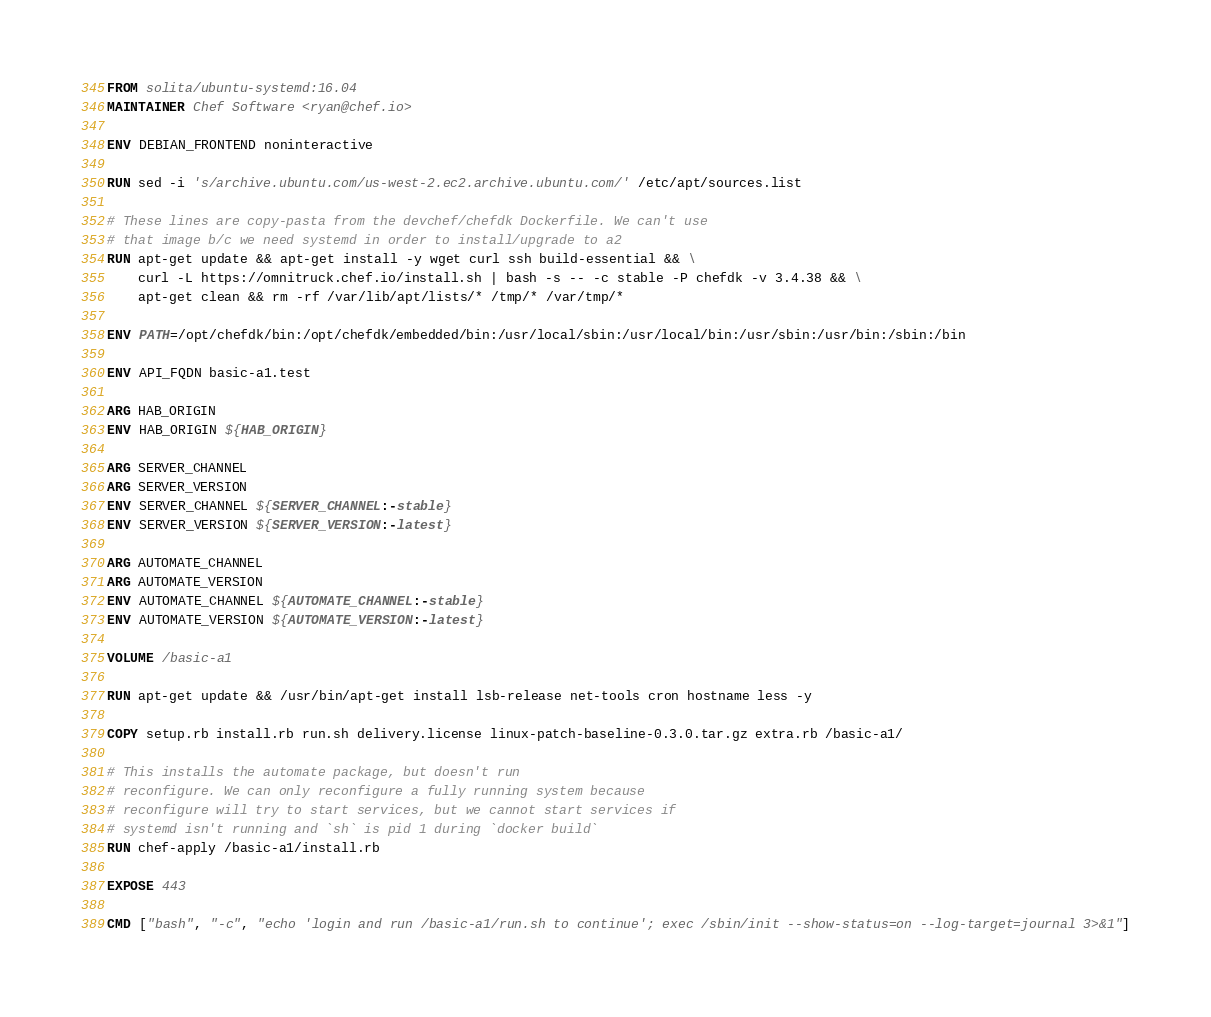Convert code to text. <code><loc_0><loc_0><loc_500><loc_500><_Dockerfile_>FROM solita/ubuntu-systemd:16.04
MAINTAINER Chef Software <ryan@chef.io>

ENV DEBIAN_FRONTEND noninteractive

RUN sed -i 's/archive.ubuntu.com/us-west-2.ec2.archive.ubuntu.com/' /etc/apt/sources.list

# These lines are copy-pasta from the devchef/chefdk Dockerfile. We can't use
# that image b/c we need systemd in order to install/upgrade to a2
RUN apt-get update && apt-get install -y wget curl ssh build-essential && \
    curl -L https://omnitruck.chef.io/install.sh | bash -s -- -c stable -P chefdk -v 3.4.38 && \
    apt-get clean && rm -rf /var/lib/apt/lists/* /tmp/* /var/tmp/*

ENV PATH=/opt/chefdk/bin:/opt/chefdk/embedded/bin:/usr/local/sbin:/usr/local/bin:/usr/sbin:/usr/bin:/sbin:/bin

ENV API_FQDN basic-a1.test

ARG HAB_ORIGIN
ENV HAB_ORIGIN ${HAB_ORIGIN}

ARG SERVER_CHANNEL
ARG SERVER_VERSION
ENV SERVER_CHANNEL ${SERVER_CHANNEL:-stable}
ENV SERVER_VERSION ${SERVER_VERSION:-latest}

ARG AUTOMATE_CHANNEL
ARG AUTOMATE_VERSION
ENV AUTOMATE_CHANNEL ${AUTOMATE_CHANNEL:-stable}
ENV AUTOMATE_VERSION ${AUTOMATE_VERSION:-latest}

VOLUME /basic-a1

RUN apt-get update && /usr/bin/apt-get install lsb-release net-tools cron hostname less -y

COPY setup.rb install.rb run.sh delivery.license linux-patch-baseline-0.3.0.tar.gz extra.rb /basic-a1/

# This installs the automate package, but doesn't run
# reconfigure. We can only reconfigure a fully running system because
# reconfigure will try to start services, but we cannot start services if
# systemd isn't running and `sh` is pid 1 during `docker build`
RUN chef-apply /basic-a1/install.rb

EXPOSE 443

CMD ["bash", "-c", "echo 'login and run /basic-a1/run.sh to continue'; exec /sbin/init --show-status=on --log-target=journal 3>&1"]
</code> 